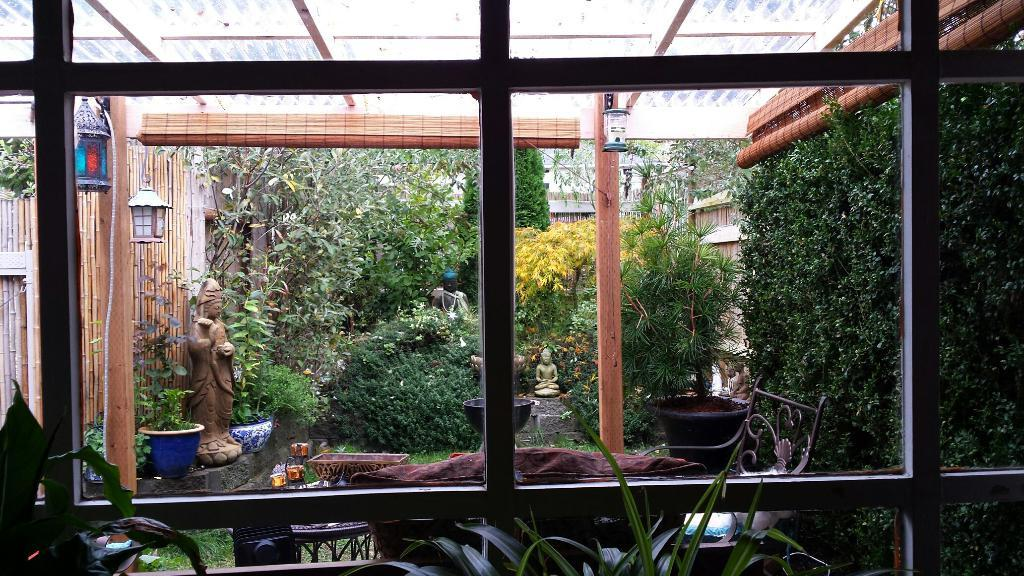What type of living organisms can be seen in the image? Plants, trees, and house plants are visible in the image. What is the purpose of the bowl in the image? The purpose of the bowl is not specified, but it could be used for holding water or other items. What type of art is present in the image? Sculptures are present in the image. What type of lighting is visible in the image? Lanterns are visible in the image. What type of furniture is present in the image? There is a chair in the image. What type of structures can be seen in the background of the image? Buildings are visible in the background of the image. What type of rake is used to maintain the plants in the image? There is no rake present in the image; it only features plants, trees, and house plants. What type of station is visible in the background of the image? There is no station present in the image; it only features buildings in the background. 